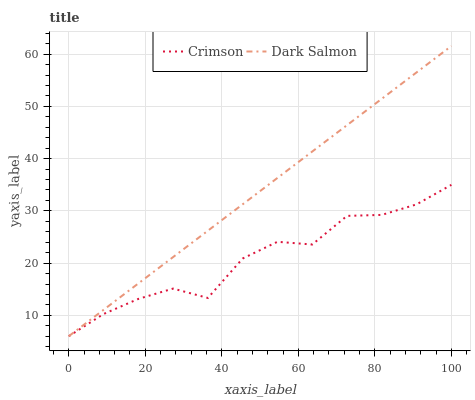Does Dark Salmon have the minimum area under the curve?
Answer yes or no. No. Is Dark Salmon the roughest?
Answer yes or no. No. 